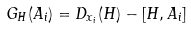Convert formula to latex. <formula><loc_0><loc_0><loc_500><loc_500>G _ { H } ( A _ { i } ) = D _ { x _ { i } } ( H ) - [ H , A _ { i } ]</formula> 